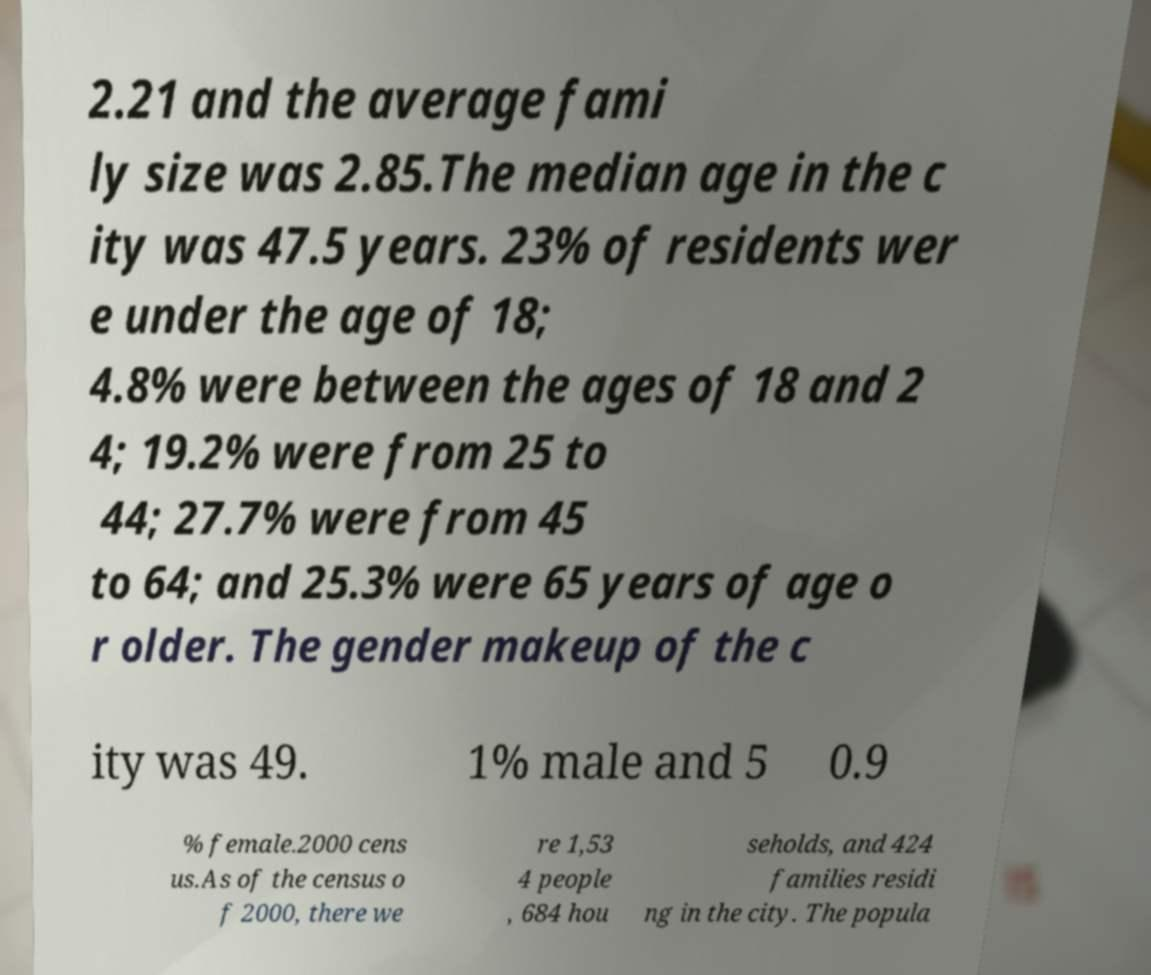Could you extract and type out the text from this image? 2.21 and the average fami ly size was 2.85.The median age in the c ity was 47.5 years. 23% of residents wer e under the age of 18; 4.8% were between the ages of 18 and 2 4; 19.2% were from 25 to 44; 27.7% were from 45 to 64; and 25.3% were 65 years of age o r older. The gender makeup of the c ity was 49. 1% male and 5 0.9 % female.2000 cens us.As of the census o f 2000, there we re 1,53 4 people , 684 hou seholds, and 424 families residi ng in the city. The popula 